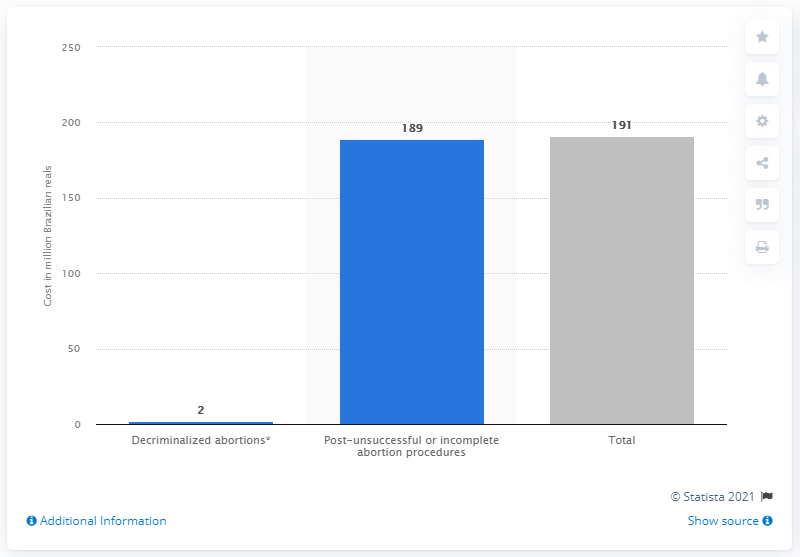Mention a couple of crucial points in this snapshot. In the same period, the amount of real funds spent on health expenditures due to unsuccessful or incomplete abortions was approximately 189.. 